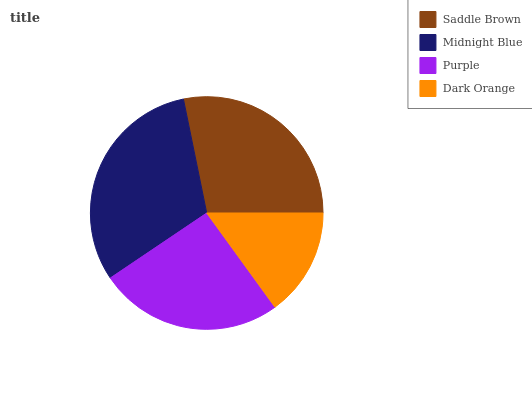Is Dark Orange the minimum?
Answer yes or no. Yes. Is Midnight Blue the maximum?
Answer yes or no. Yes. Is Purple the minimum?
Answer yes or no. No. Is Purple the maximum?
Answer yes or no. No. Is Midnight Blue greater than Purple?
Answer yes or no. Yes. Is Purple less than Midnight Blue?
Answer yes or no. Yes. Is Purple greater than Midnight Blue?
Answer yes or no. No. Is Midnight Blue less than Purple?
Answer yes or no. No. Is Saddle Brown the high median?
Answer yes or no. Yes. Is Purple the low median?
Answer yes or no. Yes. Is Purple the high median?
Answer yes or no. No. Is Saddle Brown the low median?
Answer yes or no. No. 